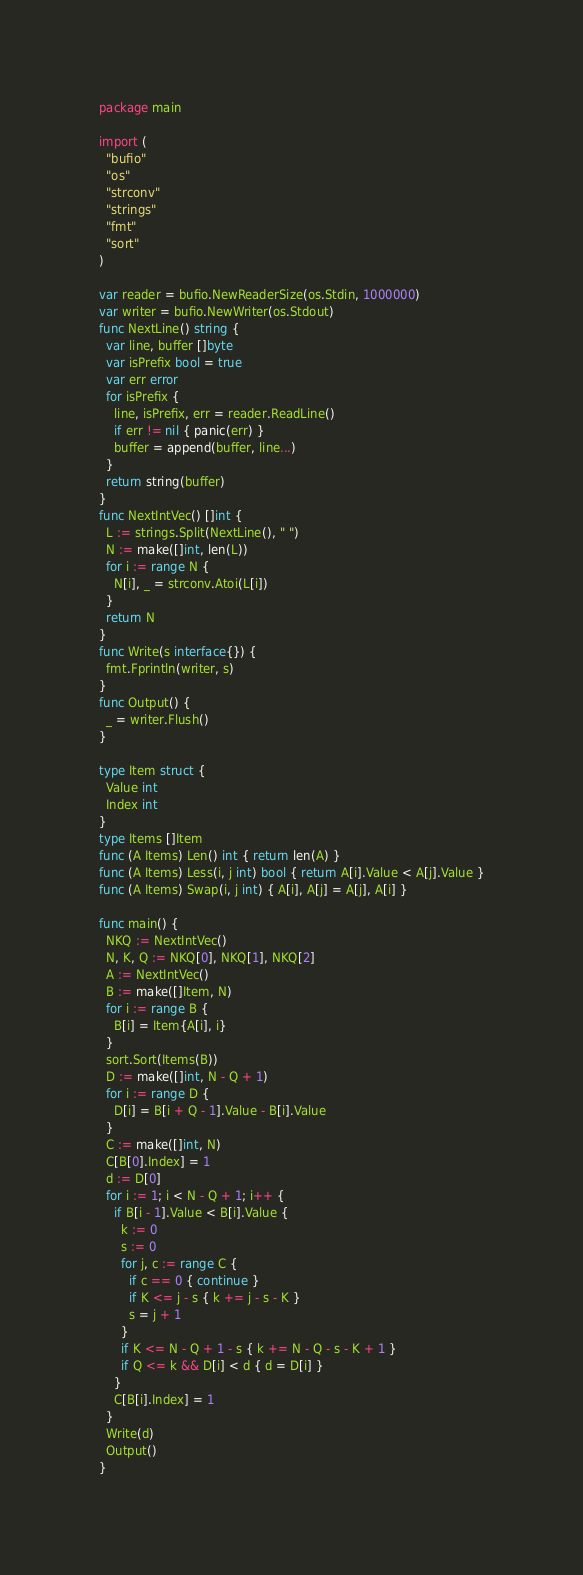Convert code to text. <code><loc_0><loc_0><loc_500><loc_500><_Go_>package main
 
import (
  "bufio"
  "os"
  "strconv"
  "strings"
  "fmt"
  "sort"
)
 
var reader = bufio.NewReaderSize(os.Stdin, 1000000)
var writer = bufio.NewWriter(os.Stdout)
func NextLine() string {
  var line, buffer []byte
  var isPrefix bool = true
  var err error
  for isPrefix {
    line, isPrefix, err = reader.ReadLine()
    if err != nil { panic(err) }
    buffer = append(buffer, line...)
  }
  return string(buffer)
}
func NextIntVec() []int {
  L := strings.Split(NextLine(), " ")
  N := make([]int, len(L))
  for i := range N {
    N[i], _ = strconv.Atoi(L[i])
  }
  return N
}
func Write(s interface{}) {
  fmt.Fprintln(writer, s)
}
func Output() {
  _ = writer.Flush()
}

type Item struct {
  Value int
  Index int
}
type Items []Item
func (A Items) Len() int { return len(A) }
func (A Items) Less(i, j int) bool { return A[i].Value < A[j].Value }
func (A Items) Swap(i, j int) { A[i], A[j] = A[j], A[i] }

func main() {
  NKQ := NextIntVec()
  N, K, Q := NKQ[0], NKQ[1], NKQ[2]
  A := NextIntVec()
  B := make([]Item, N)
  for i := range B {
    B[i] = Item{A[i], i}
  }
  sort.Sort(Items(B))
  D := make([]int, N - Q + 1)
  for i := range D {
    D[i] = B[i + Q - 1].Value - B[i].Value
  }
  C := make([]int, N)
  C[B[0].Index] = 1
  d := D[0]
  for i := 1; i < N - Q + 1; i++ {
    if B[i - 1].Value < B[i].Value {
      k := 0
      s := 0
      for j, c := range C {
        if c == 0 { continue }
        if K <= j - s { k += j - s - K }
        s = j + 1
      }
      if K <= N - Q + 1 - s { k += N - Q - s - K + 1 }
      if Q <= k && D[i] < d { d = D[i] }
    }
    C[B[i].Index] = 1
  }
  Write(d)
  Output()
}</code> 